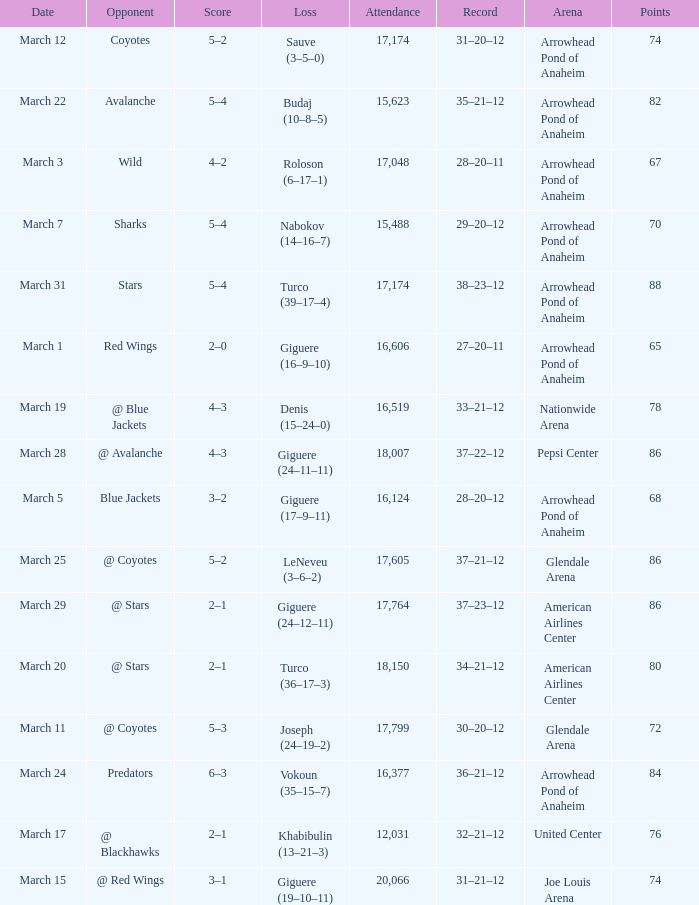What is the Attendance of the game with a Score of 3–2? 1.0. 